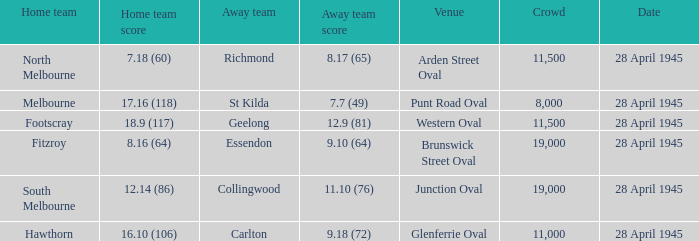Which away team has a Home team score of 12.14 (86)? 11.10 (76). 